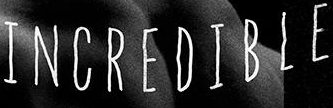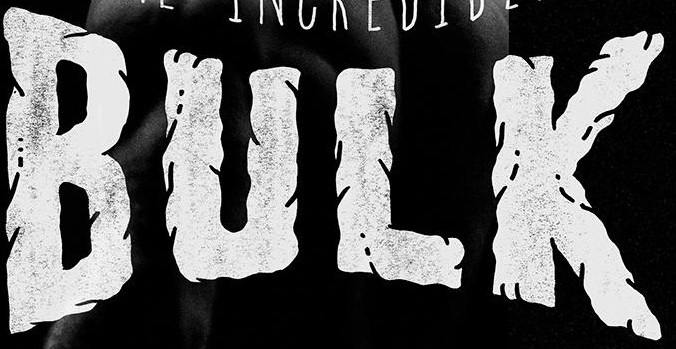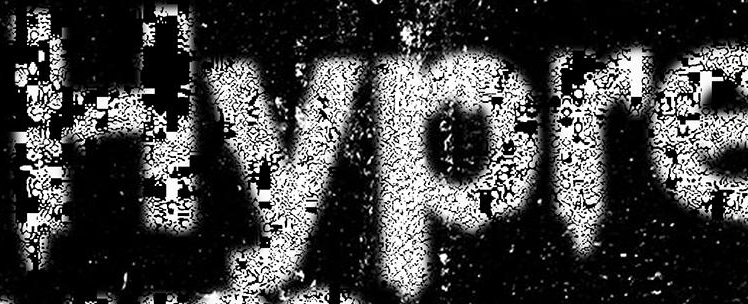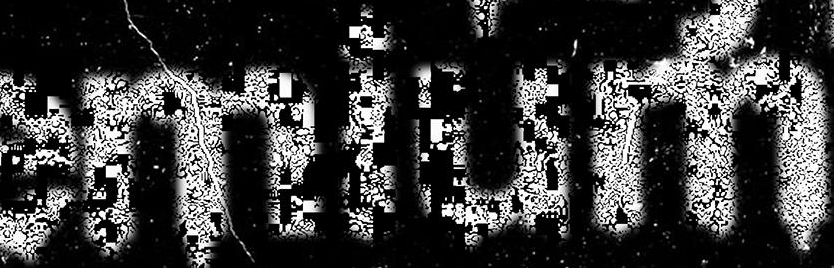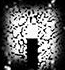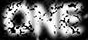Transcribe the words shown in these images in order, separated by a semicolon. INCREDIBLE; BULK; Hypre; emium; .; ONE 